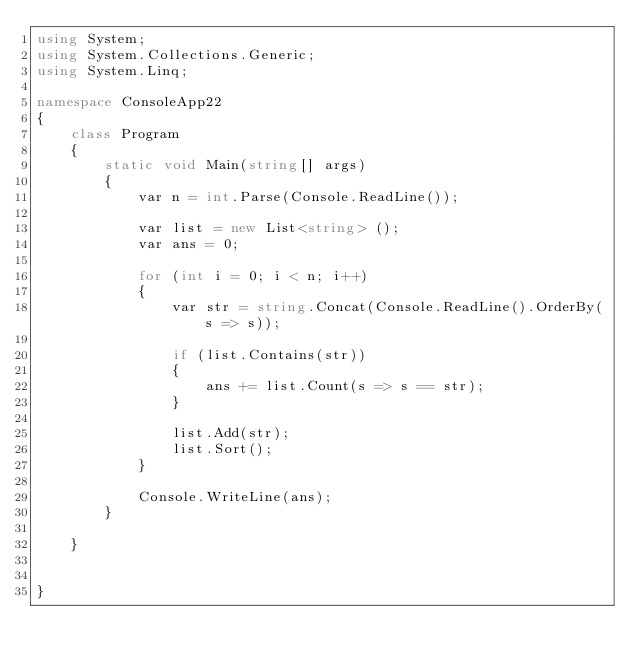Convert code to text. <code><loc_0><loc_0><loc_500><loc_500><_C#_>using System;
using System.Collections.Generic;
using System.Linq;

namespace ConsoleApp22
{
    class Program
    {
        static void Main(string[] args)
        {
            var n = int.Parse(Console.ReadLine());

            var list = new List<string> ();
            var ans = 0;

            for (int i = 0; i < n; i++)
            {
                var str = string.Concat(Console.ReadLine().OrderBy(s => s));

                if (list.Contains(str))
                {
                    ans += list.Count(s => s == str);
                }

                list.Add(str);
                list.Sort();
            }

            Console.WriteLine(ans);
        }

    }


}
</code> 